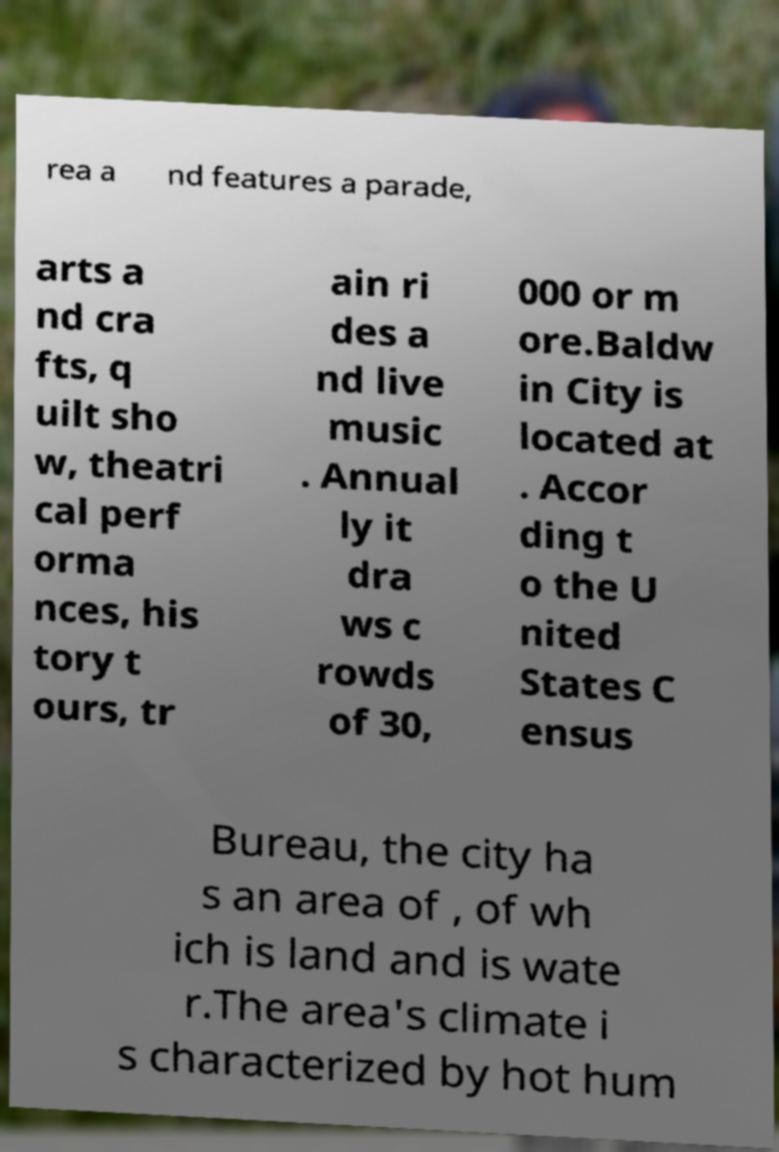Can you read and provide the text displayed in the image?This photo seems to have some interesting text. Can you extract and type it out for me? rea a nd features a parade, arts a nd cra fts, q uilt sho w, theatri cal perf orma nces, his tory t ours, tr ain ri des a nd live music . Annual ly it dra ws c rowds of 30, 000 or m ore.Baldw in City is located at . Accor ding t o the U nited States C ensus Bureau, the city ha s an area of , of wh ich is land and is wate r.The area's climate i s characterized by hot hum 